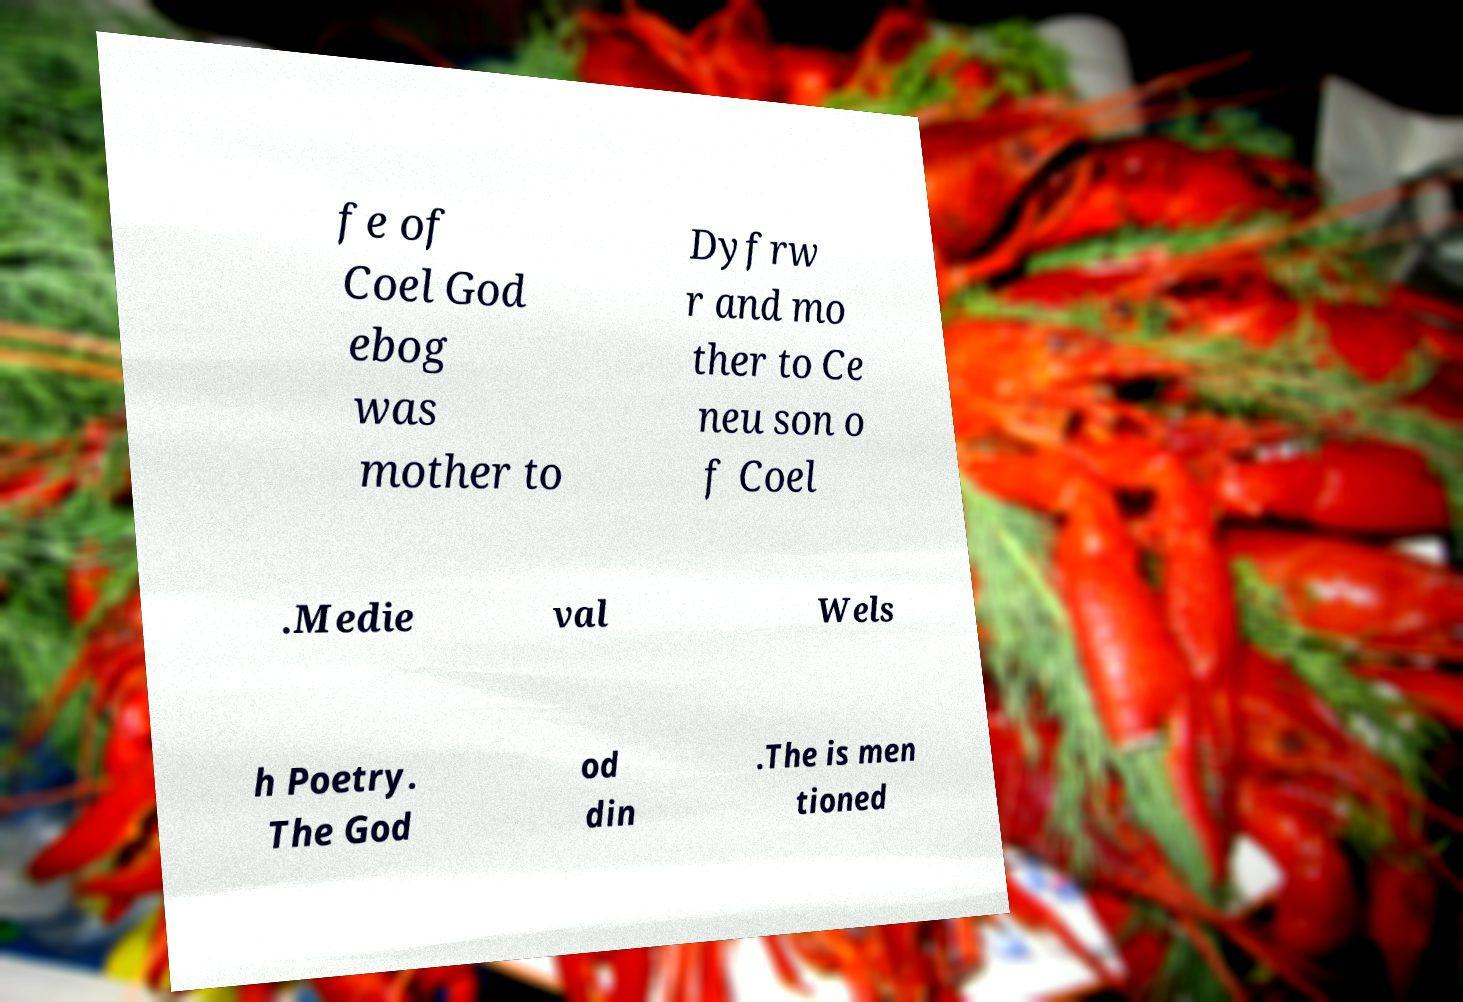Please read and relay the text visible in this image. What does it say? fe of Coel God ebog was mother to Dyfrw r and mo ther to Ce neu son o f Coel .Medie val Wels h Poetry. The God od din .The is men tioned 